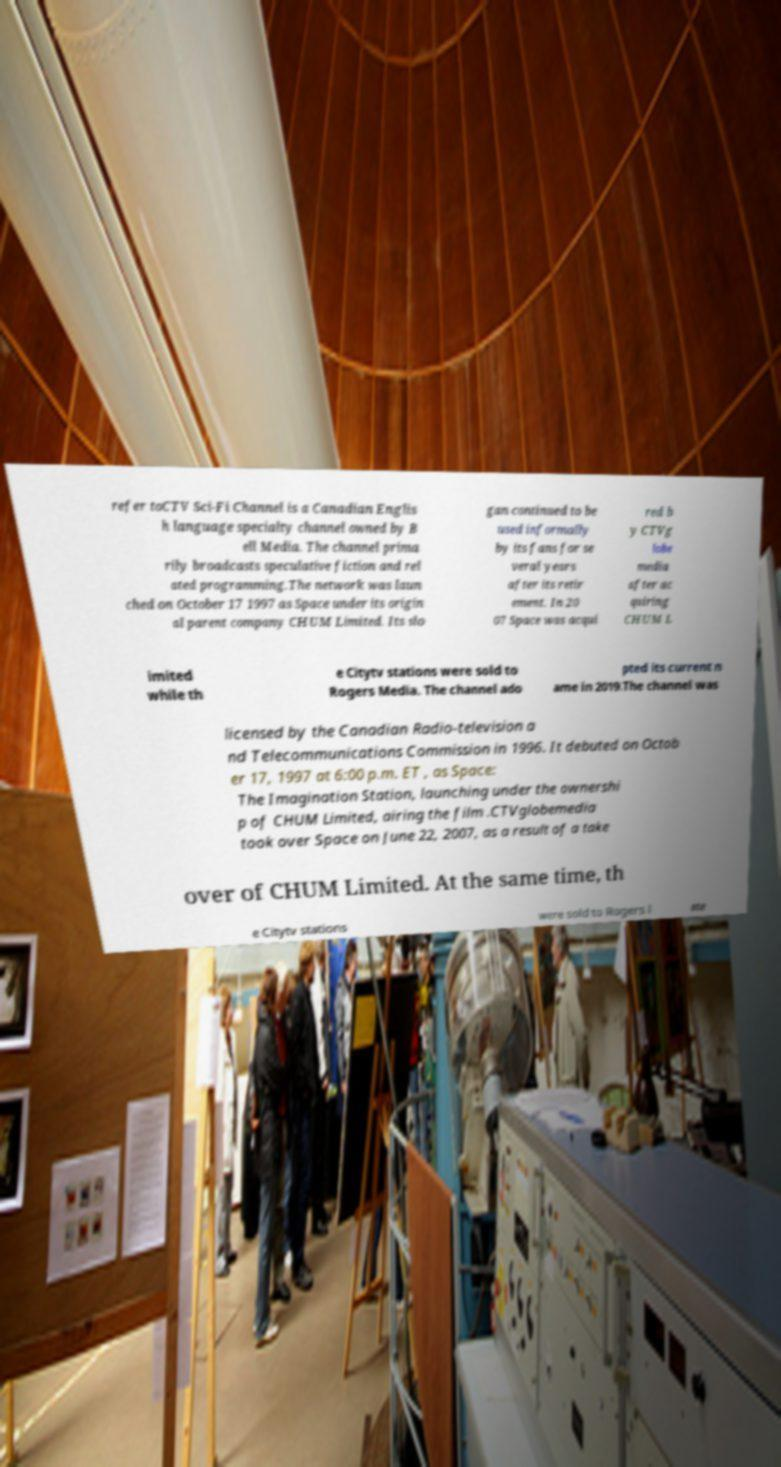Can you accurately transcribe the text from the provided image for me? refer toCTV Sci-Fi Channel is a Canadian Englis h language specialty channel owned by B ell Media. The channel prima rily broadcasts speculative fiction and rel ated programming.The network was laun ched on October 17 1997 as Space under its origin al parent company CHUM Limited. Its slo gan continued to be used informally by its fans for se veral years after its retir ement. In 20 07 Space was acqui red b y CTVg lobe media after ac quiring CHUM L imited while th e Citytv stations were sold to Rogers Media. The channel ado pted its current n ame in 2019.The channel was licensed by the Canadian Radio-television a nd Telecommunications Commission in 1996. It debuted on Octob er 17, 1997 at 6:00 p.m. ET , as Space: The Imagination Station, launching under the ownershi p of CHUM Limited, airing the film .CTVglobemedia took over Space on June 22, 2007, as a result of a take over of CHUM Limited. At the same time, th e Citytv stations were sold to Rogers l ate 